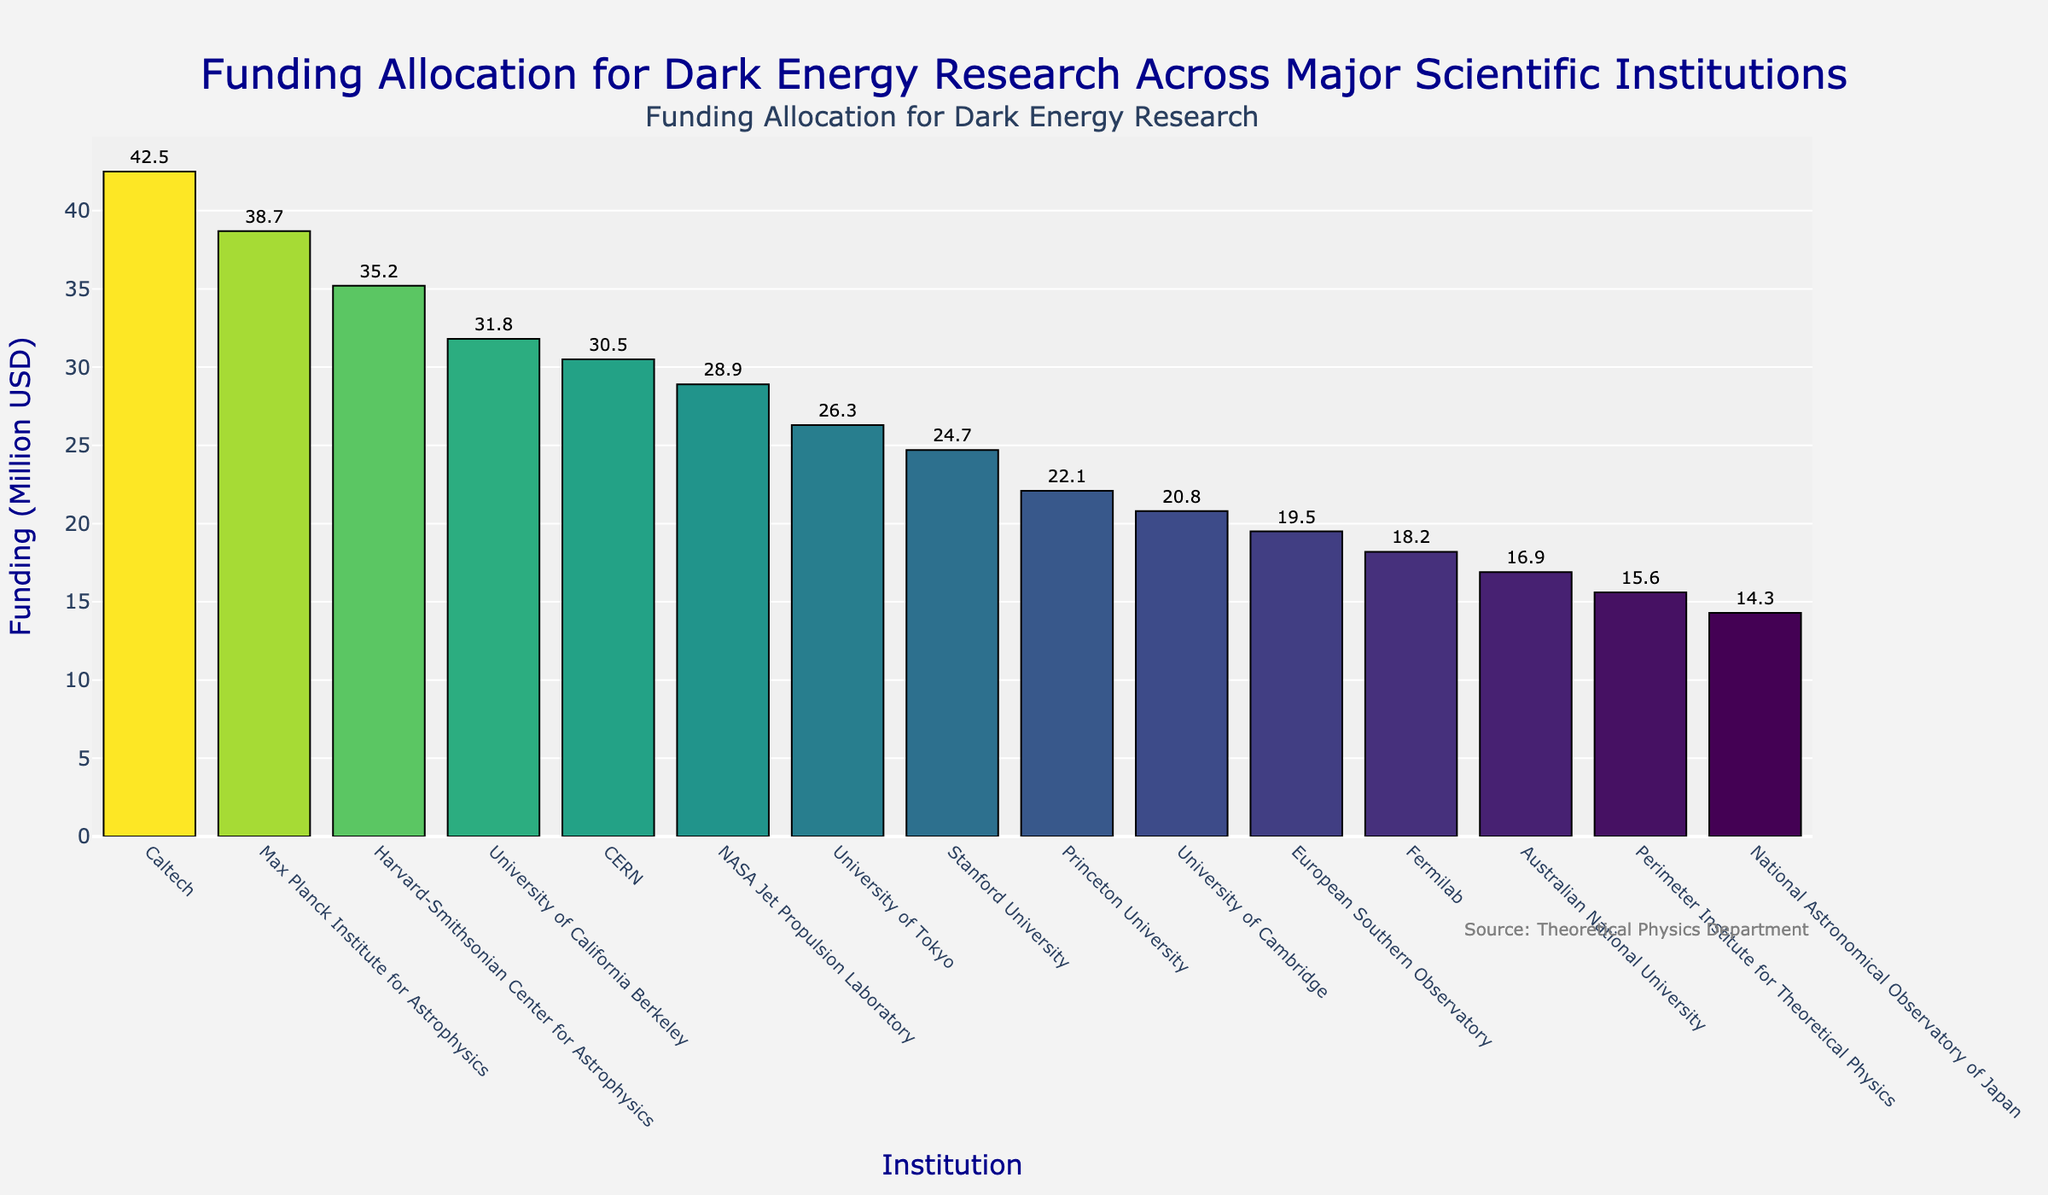Which institution received the highest funding? To determine the institution with the highest funding, look at the tallest bar in the bar chart. The tallest bar corresponds to Caltech.
Answer: Caltech Which institution received the least funding? To determine the institution with the least funding, look at the shortest bar in the bar chart. The shortest bar corresponds to the National Astronomical Observatory of Japan.
Answer: National Astronomical Observatory of Japan How much more funding did Caltech receive compared to CERN? Locate the bars representing Caltech and CERN. Caltech received $42.5M, and CERN received $30.5M. Subtract CERN's funding from Caltech's: 42.5 - 30.5 = 12
Answer: $12M Which institution has the median funding value, and what is that value? To find the median funding, list all the funding values in order and find the middle one. Ordered funding values: 14.3, 15.6, 16.9, 18.2, 19.5, 20.8, 22.1, 24.7, 26.3, 28.9, 30.5, 31.8, 35.2, 38.7, 42.5. The middle value is the eighth one: 24.7, which is Stanford University.
Answer: Stanford University, $24.7M How much is the total funding across all institutions? Sum up all the funding values. Total funding = 42.5+38.7+35.2+31.8+30.5+28.9+26.3+24.7+22.1+20.8+19.5+18.2+16.9+15.6+14.3 = 386.0
Answer: $386M Which two institutions have the closest funding amounts? Compare the differences between consecutive funding amounts in the ordered list. Closest funding values: 15.6 (Perimeter Institute) and 16.9 (Australian National University). Difference: 16.9 - 15.6 = 1.3
Answer: Perimeter Institute and Australian National University How does the funding for the Harvard-Smithsonian Center for Astrophysics compare to that of the Max Planck Institute for Astrophysics? Locate the bars for both institutions. The Harvard-Smithsonian Center received $35.2M, and the Max Planck Institute received $38.7. So the Max Planck Institute's funding is higher.
Answer: Max Planck Institute for Astrophysics received more Which two institutions collectively received more funding than the University of California Berkeley? Look for pairs of institutions whose funding sums to more than $31.8M. The two institutions with closest funding under $15.9M each sum more than Berkeley: Perimeter Institute ($15.6M) and National Astronomical Observatory of Japan ($14.3M).
Answer: Perimeter Institute and National Astronomical Observatory of Japan What percentage of the total funding was allocated to Caltech? Calculate the percentage of total funding received by Caltech: (42.5 / 386) * 100 = ~11.01%
Answer: ~11.01% How many institutions received more than $30 million in funding? Count the number of bars taller than the $30M threshold. These institutions are Caltech, Max Planck Institute, Harvard-Smithsonian, University of California Berkeley, and CERN.
Answer: 5 